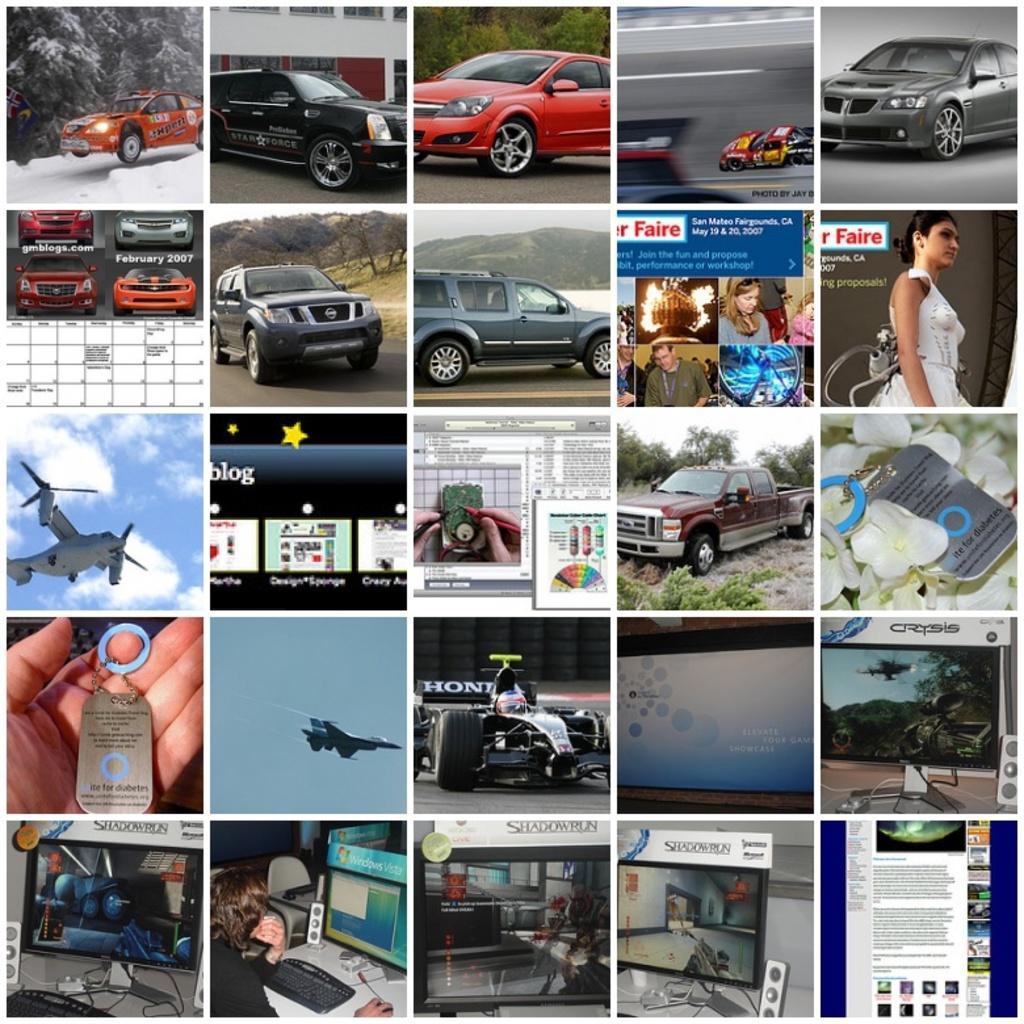How would you summarize this image in a sentence or two? In this image I can see a few cars,aeroplanes,keychain,television,keyboard,system,mouse,speaker,papers,screen and few people. They are in different color. The sky is in blue and white color. It is a collage image. 